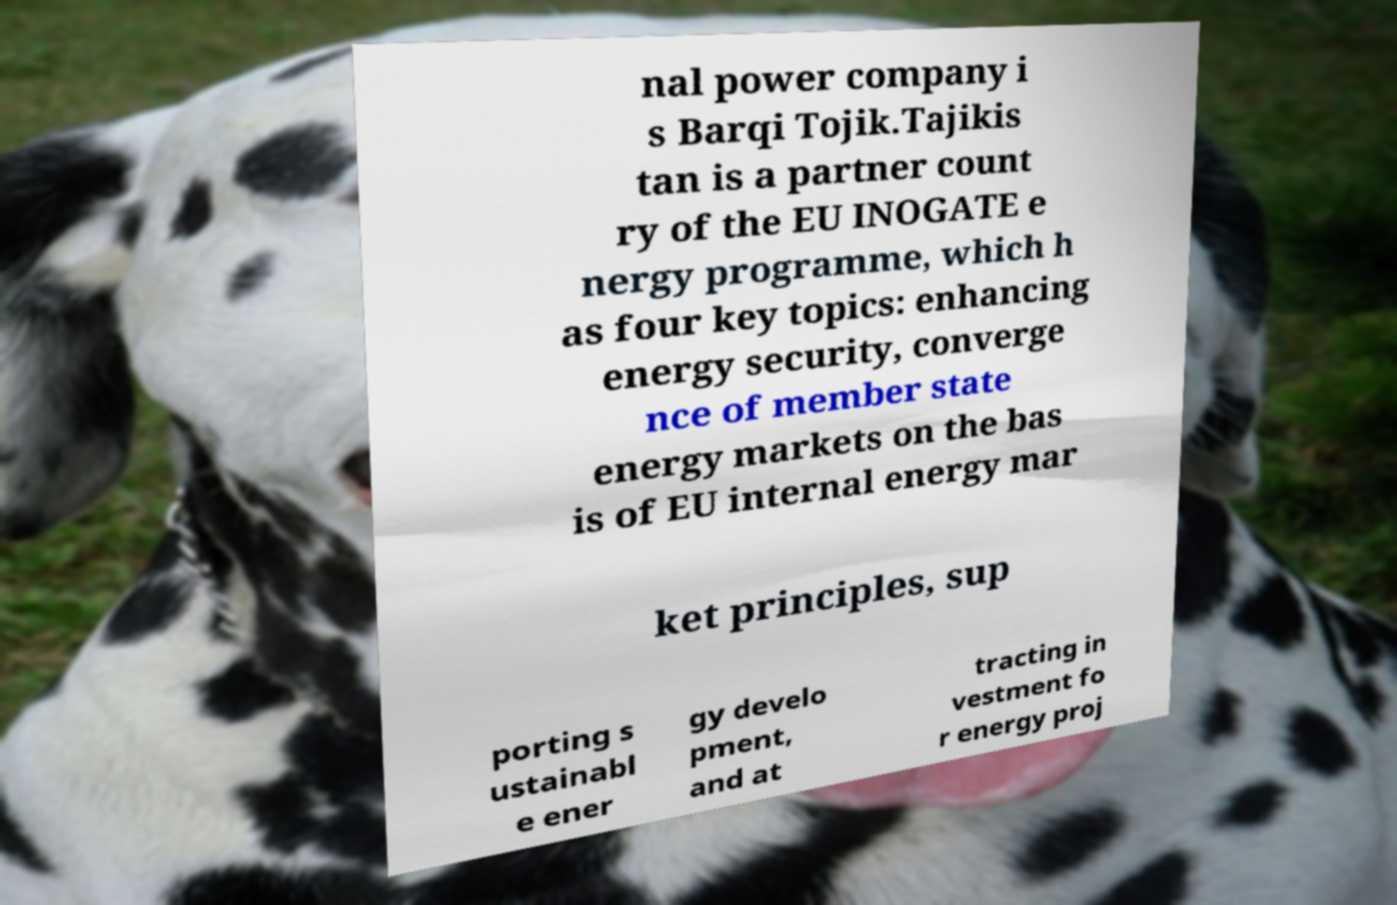For documentation purposes, I need the text within this image transcribed. Could you provide that? nal power company i s Barqi Tojik.Tajikis tan is a partner count ry of the EU INOGATE e nergy programme, which h as four key topics: enhancing energy security, converge nce of member state energy markets on the bas is of EU internal energy mar ket principles, sup porting s ustainabl e ener gy develo pment, and at tracting in vestment fo r energy proj 